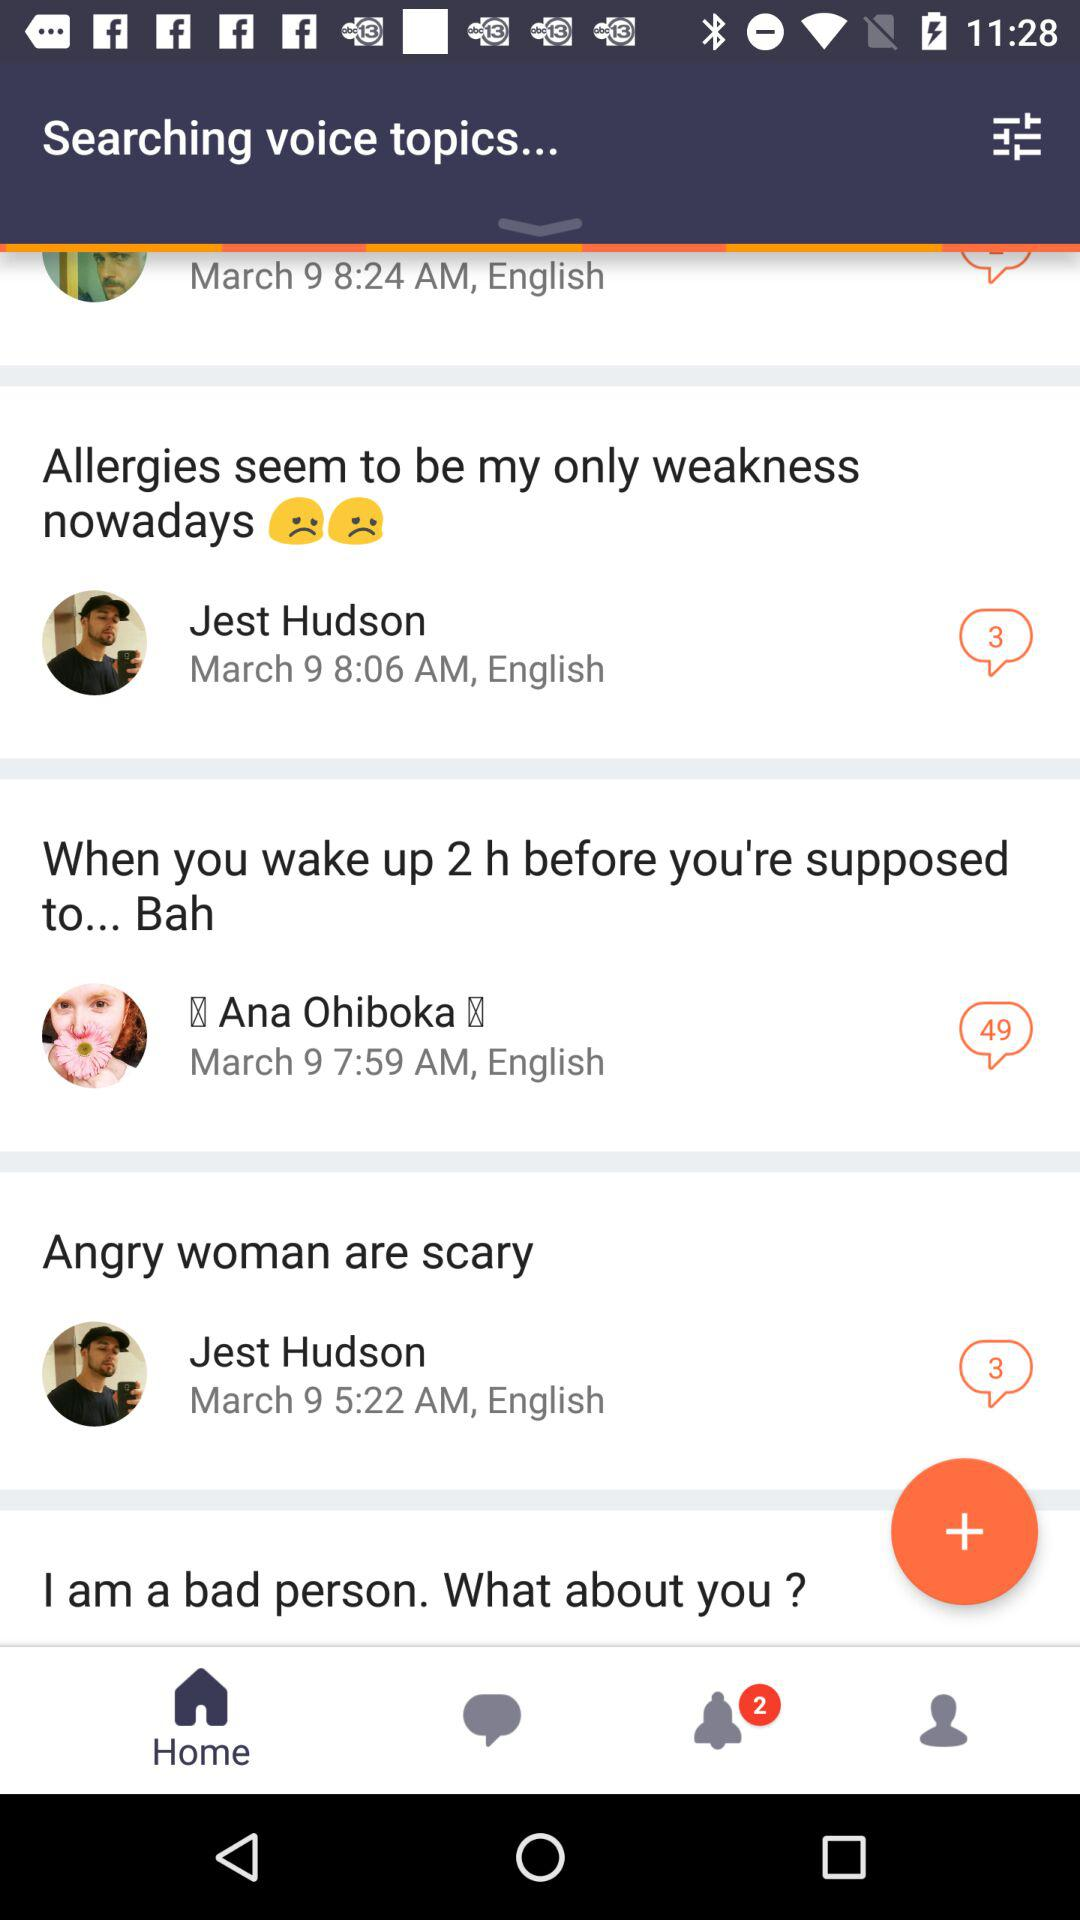What is the number of new messages for Jest Hudson? The number of new messages is 3. 